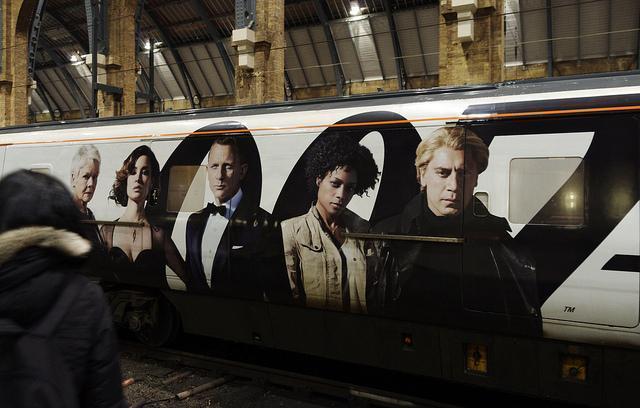Which franchise is advertised here?
Indicate the correct response and explain using: 'Answer: answer
Rationale: rationale.'
Options: James bond, sherlock holmes, x men, star wars. Answer: james bond.
Rationale: The train features an advertisement for 007 on the side. 